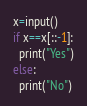<code> <loc_0><loc_0><loc_500><loc_500><_Python_>x=input()
if x==x[::-1]:
  print("Yes")
else:
  print("No")</code> 